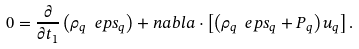Convert formula to latex. <formula><loc_0><loc_0><loc_500><loc_500>0 = \frac { \partial } { \partial t _ { 1 } } \left ( \rho _ { q } \ e p s _ { q } \right ) + n a b l a \cdot \left [ \left ( \rho _ { q } \ e p s _ { q } + P _ { q } \right ) u _ { q } \right ] .</formula> 